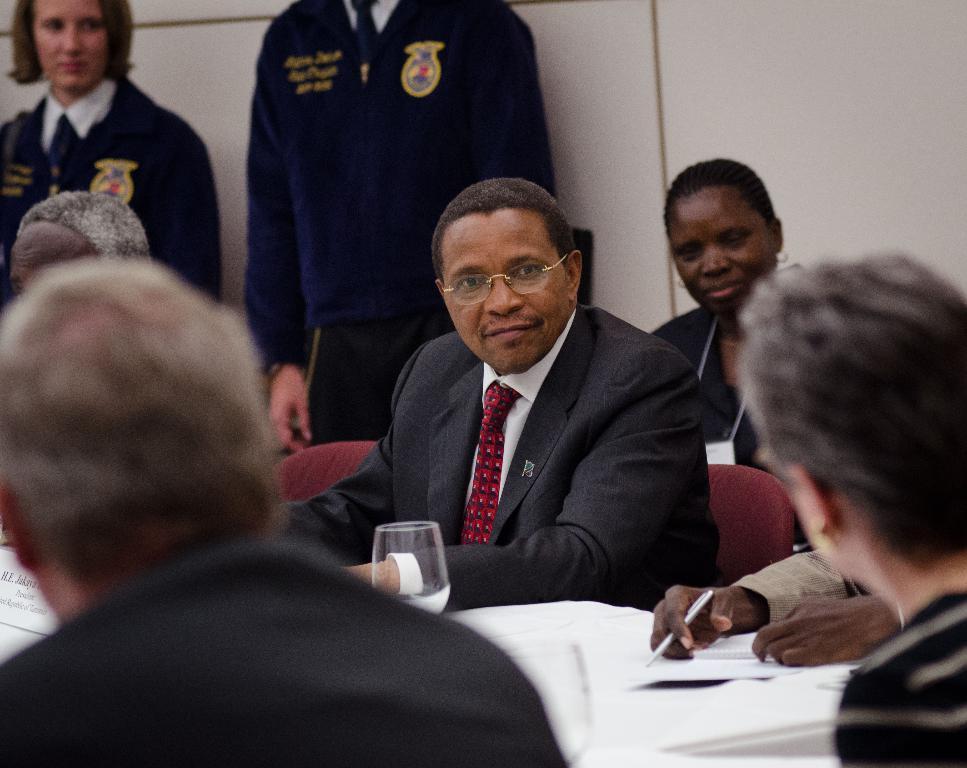Could you give a brief overview of what you see in this image? In this image I can see number of persons are sitting on chairs which are maroon in color. I can see few books and papers in front of them. In the background I can see two persons standing and the cream colored wall. 